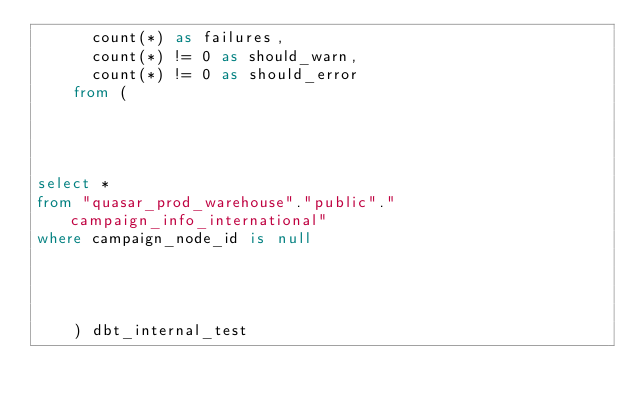<code> <loc_0><loc_0><loc_500><loc_500><_SQL_>      count(*) as failures,
      count(*) != 0 as should_warn,
      count(*) != 0 as should_error
    from (
      
    
    

select *
from "quasar_prod_warehouse"."public"."campaign_info_international"
where campaign_node_id is null



      
    ) dbt_internal_test</code> 